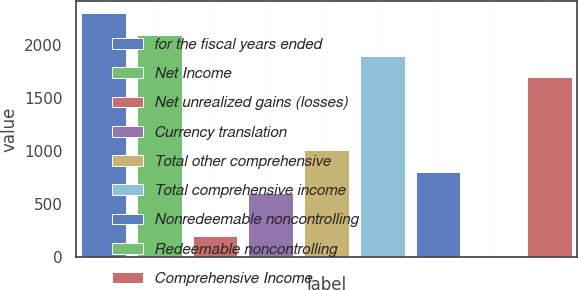Convert chart to OTSL. <chart><loc_0><loc_0><loc_500><loc_500><bar_chart><fcel>for the fiscal years ended<fcel>Net Income<fcel>Net unrealized gains (losses)<fcel>Currency translation<fcel>Total other comprehensive<fcel>Total comprehensive income<fcel>Nonredeemable noncontrolling<fcel>Redeemable noncontrolling<fcel>Comprehensive Income<nl><fcel>2297.82<fcel>2096.38<fcel>203.04<fcel>605.92<fcel>1008.8<fcel>1894.94<fcel>807.36<fcel>1.6<fcel>1693.5<nl></chart> 